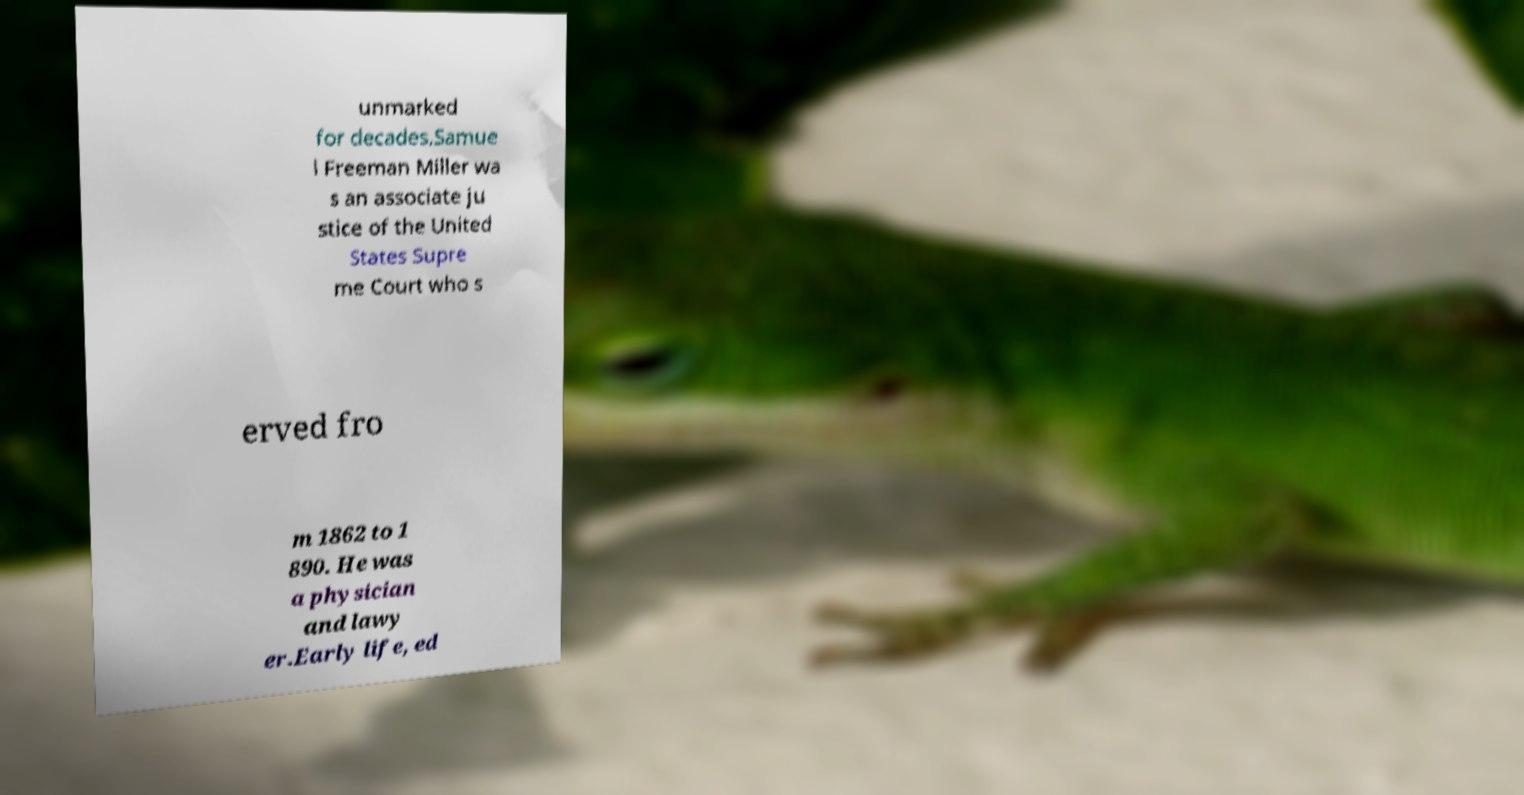Can you read and provide the text displayed in the image?This photo seems to have some interesting text. Can you extract and type it out for me? unmarked for decades.Samue l Freeman Miller wa s an associate ju stice of the United States Supre me Court who s erved fro m 1862 to 1 890. He was a physician and lawy er.Early life, ed 